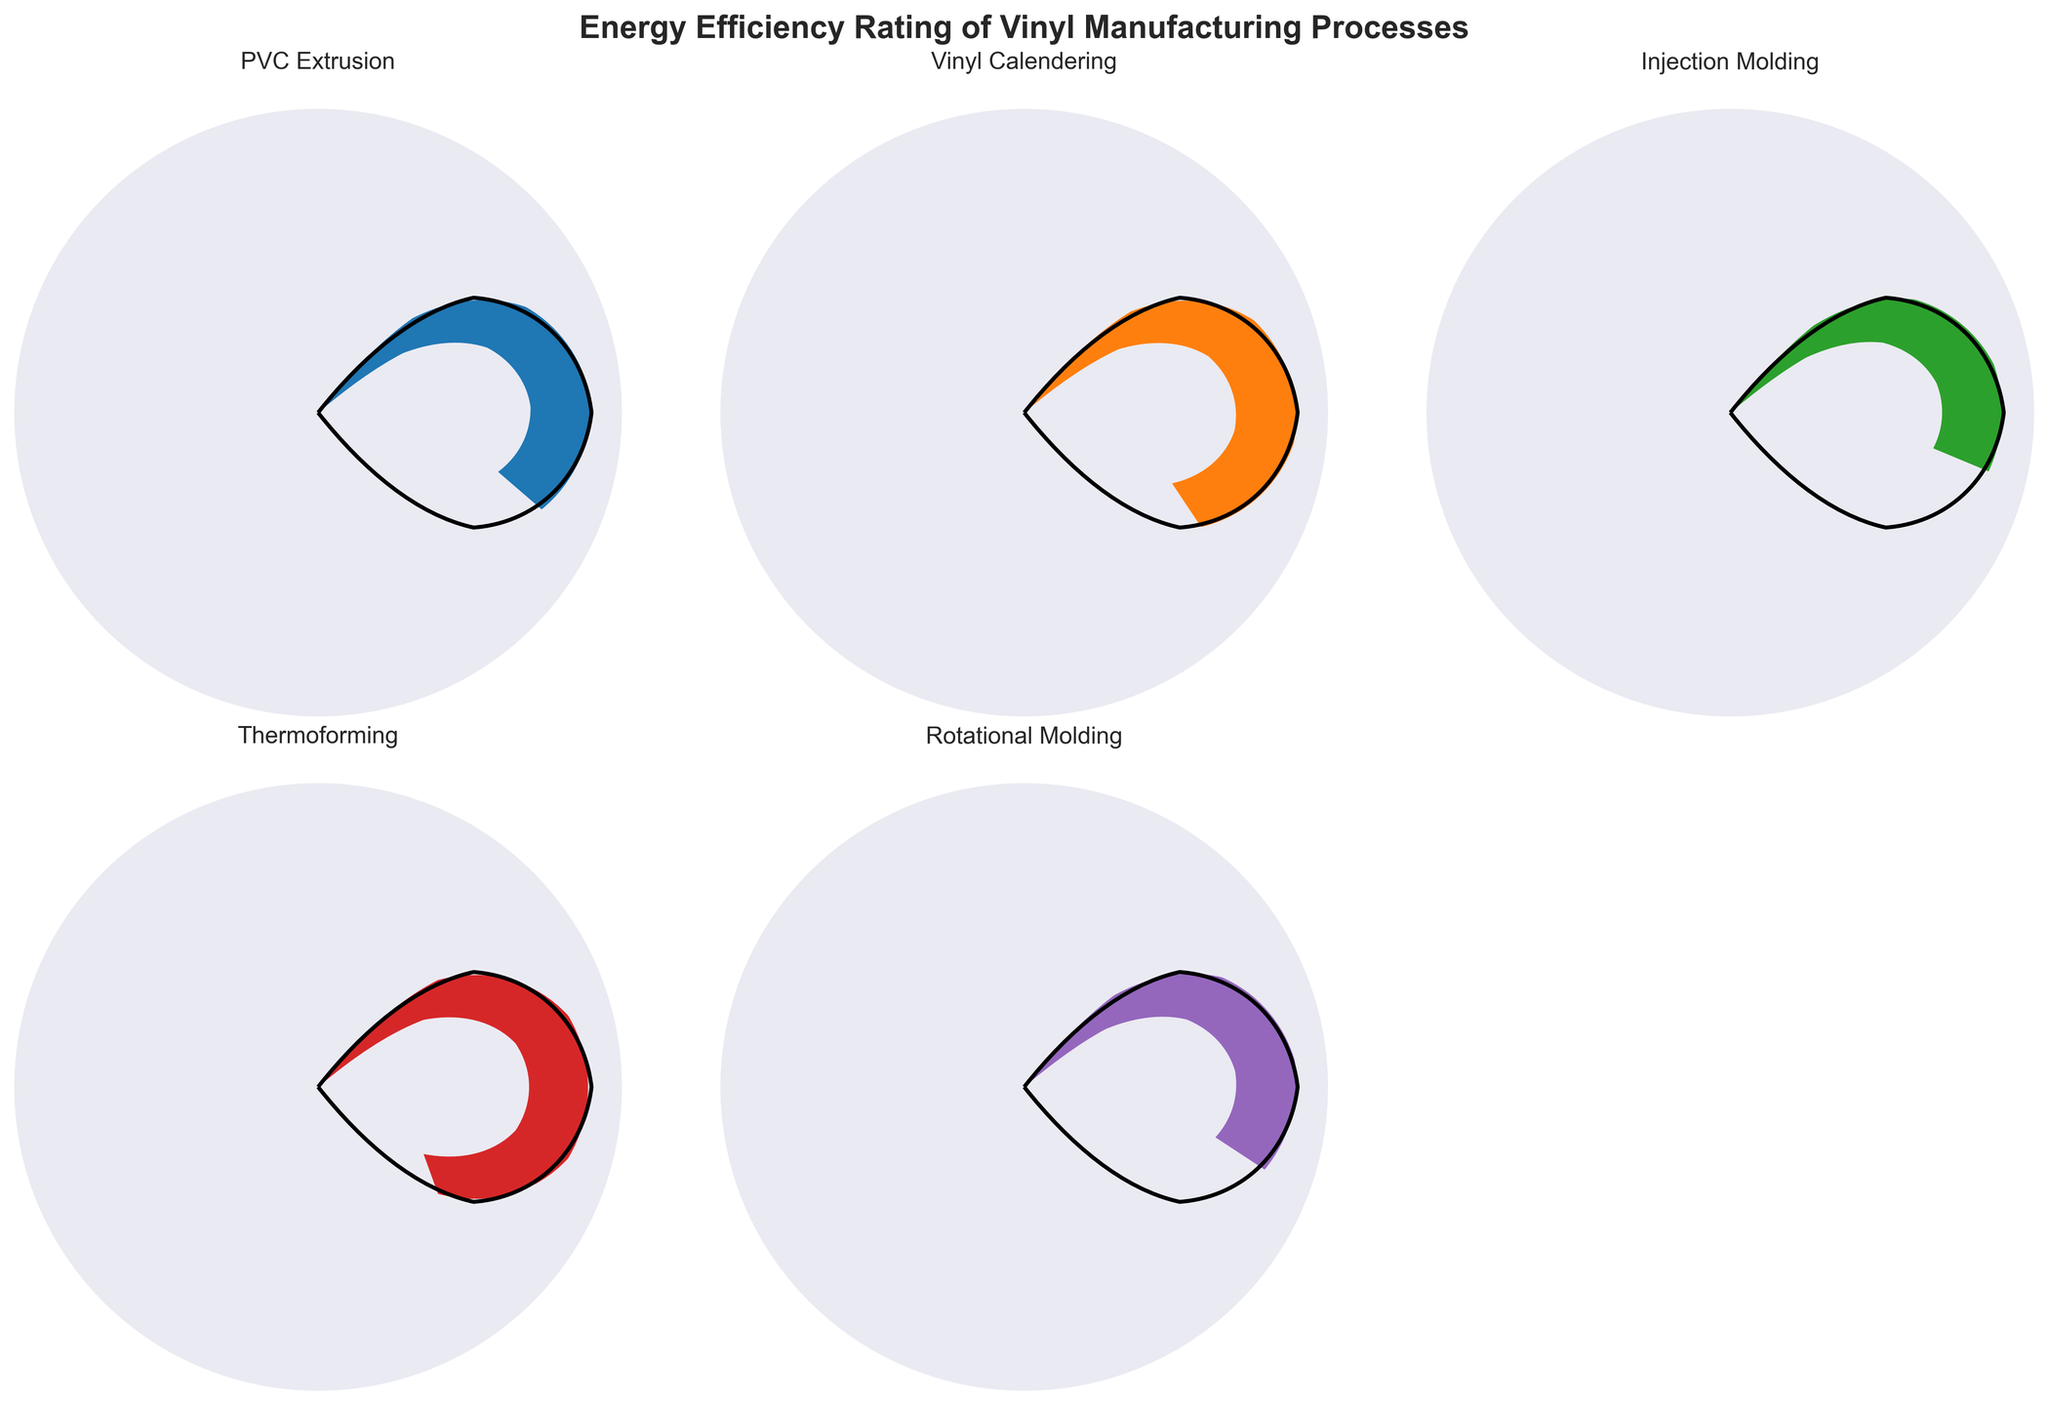What's the highest energy efficiency rating among the vinyl manufacturing processes? By visually scanning all the gauges, the process with the highest rating is identified. The 'Thermoforming' gauge shows 80%, which is the highest.
Answer: Thermoforming What is the difference in energy efficiency between Vinyl Calendering and Injection Molding? The gauge for Vinyl Calendering shows 72%, and for Injection Molding, it shows 58%. Subtracting these values gives us the difference: 72% - 58% = 14%.
Answer: 14% Which manufacturing process has the lowest energy efficiency rating? By visually inspecting all the gauges, the process with the lowest rating is evident. The 'Injection Molding' gauge displays the lowest rating of 58%.
Answer: Injection Molding Calculate the average energy efficiency rating of all the manufacturing processes represented in the figure. The values for the processes are: 65, 72, 58, 80, and 62. Adding these gives 337. Dividing by the number of processes (5) gives the average: \( \frac{337}{5} = 67.4 \).
Answer: 67.4% Which processes have an energy efficiency rating above the average value? From the previous calculation, the average rating is 67.4%. The gauges for Vinyl Calendering (72%) and Thermoforming (80%) show ratings above this average.
Answer: Vinyl Calendering, Thermoforming What is the energy efficiency rating of PVC Extrusion? By referring to the gauge labeled 'PVC Extrusion,' the displayed value is noted. The 'PVC Extrusion' gauge indicates a value of 65%.
Answer: 65% How many manufacturing processes have an energy efficiency rating of 70% or higher? By scanning the gauges, Vinyl Calendering (72%) and Thermoforming (80%) have ratings of 70% or higher. This accounts for 2 processes.
Answer: 2 Which manufacturing process has an energy efficiency rating closest to the average rating? The average rating is 67.4%. The processes have the following ratings: PVC Extrusion (65), Vinyl Calendering (72), Injection Molding (58), Thermoforming (80), Rotational Molding (62). The closest to 67.4% is PVC Extrusion with 65%.
Answer: PVC Extrusion If the energy efficiency rating of Rotational Molding improved by 10%, what would the new value be? The current rating for Rotational Molding is 62%. Adding 10% to this value results in a new rating of 72%.
Answer: 72% 